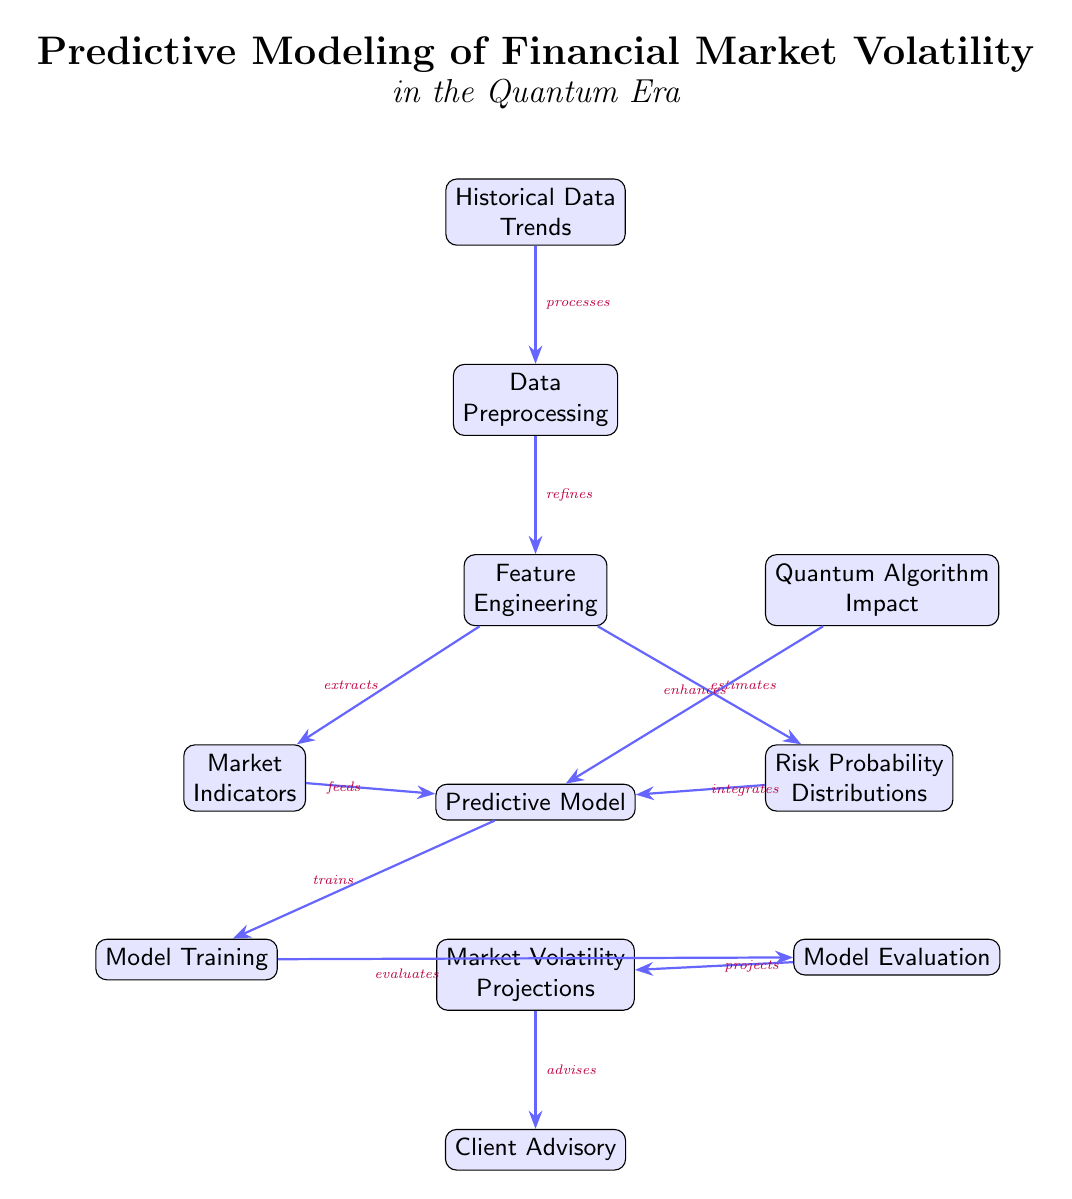What is the first node in the diagram? The first node in the diagram is "Historical Data Trends," as it is positioned at the top.
Answer: Historical Data Trends How many nodes are in the diagram? By counting all the distinct labeled nodes, we find there are a total of 9 nodes.
Answer: 9 What connects the "Feature Engineering" node with the "Risk Probability Distributions" node? The arrow from "Feature Engineering" pointing to "Risk Probability Distributions" indicates that it estimates the risk probability.
Answer: estimates Which node influences the "Predictive Model" node from the right? "Quantum Algorithm Impact" influences the "Predictive Model" node from the right side, as indicated by the arrow connecting them.
Answer: Quantum Algorithm Impact What is the function of "Model Training"? "Model Training" receives input from the "Predictive Model" node and serves to train the model, according to the connection directed towards it.
Answer: trains What is the last node in the flow of the diagram? The last node is "Client Advisory," as it is positioned at the bottom of the flow after "Market Volatility Projections."
Answer: Client Advisory What role does "Market Indicators" play in regards to the "Predictive Model"? "Market Indicators" feeds into the "Predictive Model," as indicated by their connecting arrow.
Answer: feeds How do "Data Preprocessing" and "Feature Engineering" relate to each other? "Data Preprocessing" processes the data which then refines the input for "Feature Engineering," thereby establishing a direct flow between them.
Answer: refines What is the relationship between "Model Evaluation" and "Market Volatility Projections"? "Model Evaluation" projects market volatility as it receives its input from "Predictive Model" after training takes place.
Answer: projects 